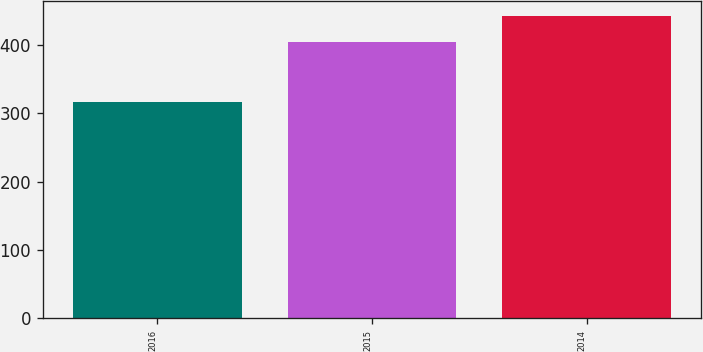Convert chart to OTSL. <chart><loc_0><loc_0><loc_500><loc_500><bar_chart><fcel>2016<fcel>2015<fcel>2014<nl><fcel>317<fcel>404<fcel>442<nl></chart> 